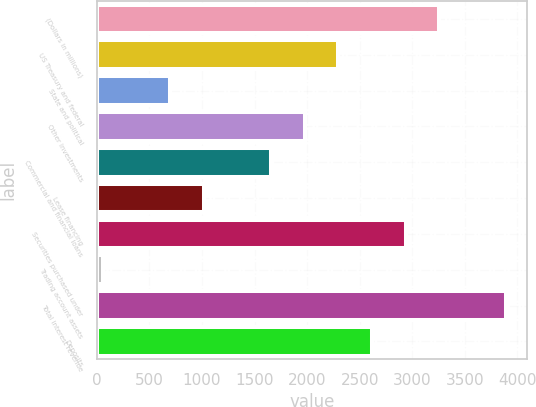<chart> <loc_0><loc_0><loc_500><loc_500><bar_chart><fcel>(Dollars in millions)<fcel>US Treasury and federal<fcel>State and political<fcel>Other investments<fcel>Commercial and financial loans<fcel>Lease financing<fcel>Securities purchased under<fcel>Trading account assets<fcel>Total interest revenue<fcel>Deposits<nl><fcel>3256<fcel>2296.9<fcel>698.4<fcel>1977.2<fcel>1657.5<fcel>1018.1<fcel>2936.3<fcel>59<fcel>3895.4<fcel>2616.6<nl></chart> 